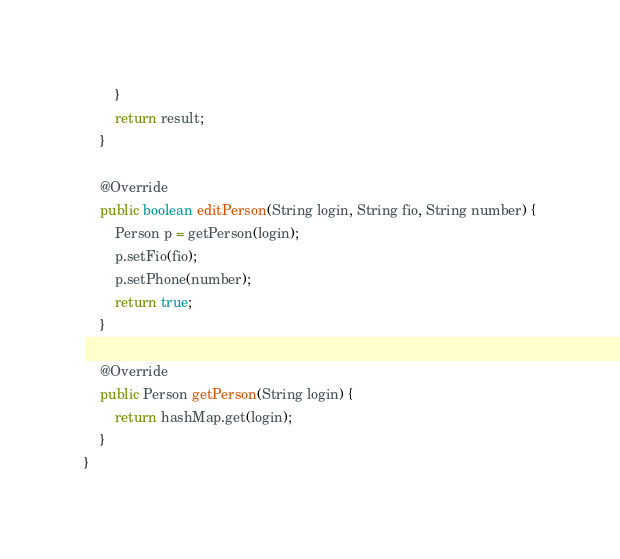<code> <loc_0><loc_0><loc_500><loc_500><_Java_>        }
        return result;
    }

    @Override
    public boolean editPerson(String login, String fio, String number) {
        Person p = getPerson(login);
        p.setFio(fio);
        p.setPhone(number);
        return true;
    }

    @Override
    public Person getPerson(String login) {
        return hashMap.get(login);
    }
}
</code> 